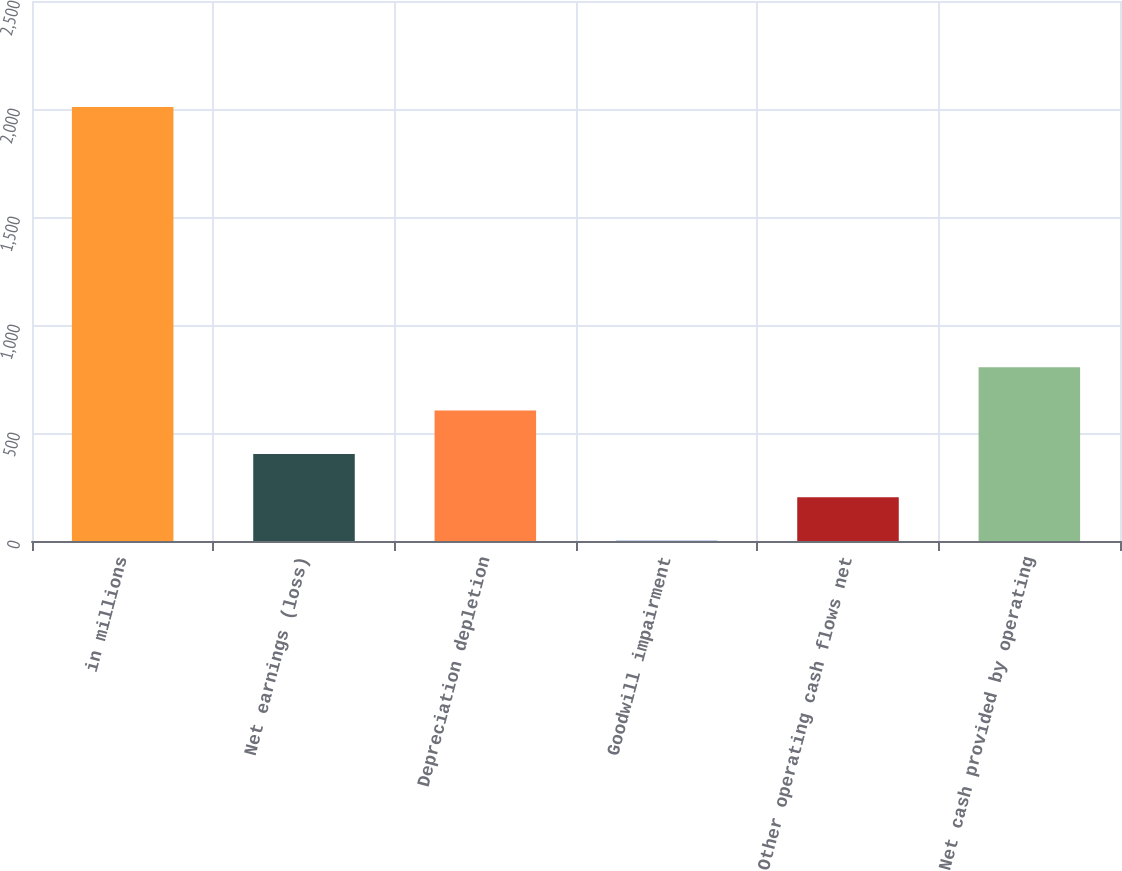Convert chart. <chart><loc_0><loc_0><loc_500><loc_500><bar_chart><fcel>in millions<fcel>Net earnings (loss)<fcel>Depreciation depletion<fcel>Goodwill impairment<fcel>Other operating cash flows net<fcel>Net cash provided by operating<nl><fcel>2009<fcel>403<fcel>603.75<fcel>1.5<fcel>202.25<fcel>804.5<nl></chart> 